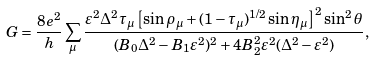<formula> <loc_0><loc_0><loc_500><loc_500>G = \frac { 8 e ^ { 2 } } { h } \sum _ { \mu } \frac { \varepsilon ^ { 2 } \Delta ^ { 2 } \tau _ { \mu } \left [ \sin \rho _ { \mu } + ( 1 - \tau _ { \mu } ) ^ { 1 / 2 } \sin \eta _ { \mu } \right ] ^ { 2 } \sin ^ { 2 } \theta } { ( B _ { 0 } \Delta ^ { 2 } - B _ { 1 } \varepsilon ^ { 2 } ) ^ { 2 } + 4 B _ { 2 } ^ { 2 } \varepsilon ^ { 2 } ( \Delta ^ { 2 } - \varepsilon ^ { 2 } ) } ,</formula> 